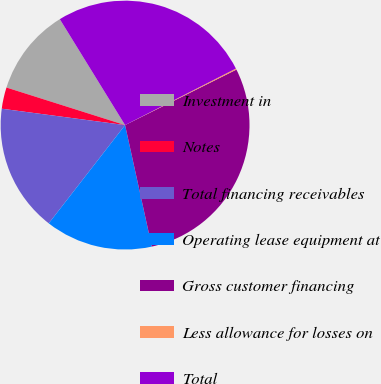Convert chart to OTSL. <chart><loc_0><loc_0><loc_500><loc_500><pie_chart><fcel>Investment in<fcel>Notes<fcel>Total financing receivables<fcel>Operating lease equipment at<fcel>Gross customer financing<fcel>Less allowance for losses on<fcel>Total<nl><fcel>11.33%<fcel>2.78%<fcel>16.59%<fcel>13.96%<fcel>28.91%<fcel>0.15%<fcel>26.28%<nl></chart> 